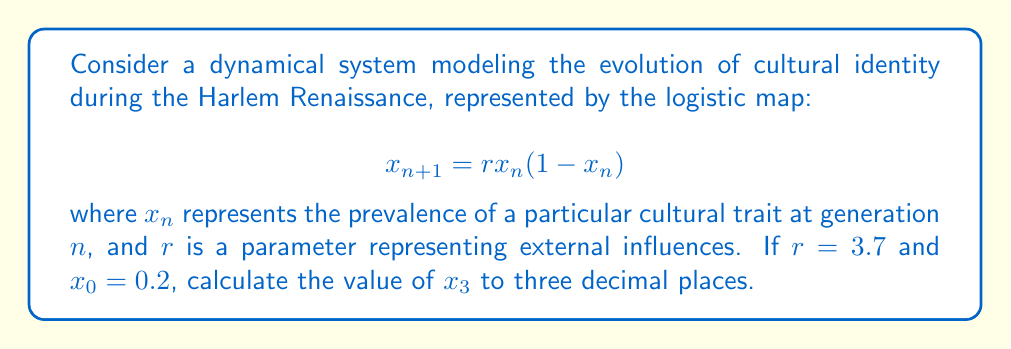Give your solution to this math problem. To solve this problem, we need to iterate the logistic map equation three times:

1. Calculate $x_1$:
   $$x_1 = r \cdot x_0(1-x_0) = 3.7 \cdot 0.2(1-0.2) = 3.7 \cdot 0.2 \cdot 0.8 = 0.592$$

2. Calculate $x_2$:
   $$x_2 = r \cdot x_1(1-x_1) = 3.7 \cdot 0.592(1-0.592) = 3.7 \cdot 0.592 \cdot 0.408 = 0.893$$

3. Calculate $x_3$:
   $$x_3 = r \cdot x_2(1-x_2) = 3.7 \cdot 0.893(1-0.893) = 3.7 \cdot 0.893 \cdot 0.107 = 0.354$$

4. Round $x_3$ to three decimal places: 0.354

This result demonstrates how a simple nonlinear equation can produce complex behavior in cultural evolution, a key concept in chaos theory applied to social dynamics.
Answer: 0.354 